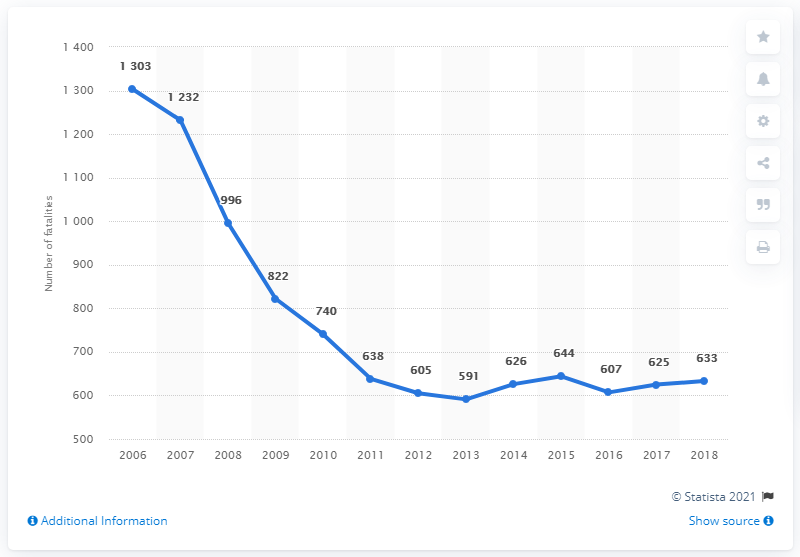List a handful of essential elements in this visual. From 2006 to 2018, the number of road and traffic fatalities in Hungary varied significantly, with the highest number of fatalities occurring in 2006 and the lowest number occurring in 2018. In Hungary, the year with the highest number of road and traffic fatalities from 2006 to 2018 was 2006. In 2018, Hungary experienced 633 fatalities due to road traffic accidents. In 2006, the highest number of road fatalities occurred. 